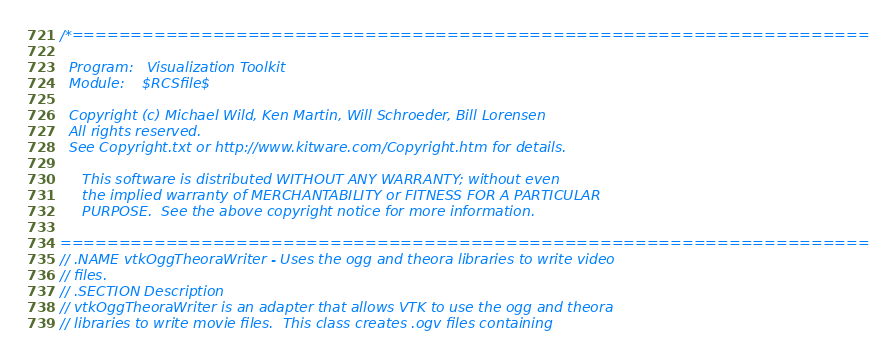Convert code to text. <code><loc_0><loc_0><loc_500><loc_500><_C_>/*=========================================================================

  Program:   Visualization Toolkit
  Module:    $RCSfile$

  Copyright (c) Michael Wild, Ken Martin, Will Schroeder, Bill Lorensen
  All rights reserved.
  See Copyright.txt or http://www.kitware.com/Copyright.htm for details.

     This software is distributed WITHOUT ANY WARRANTY; without even
     the implied warranty of MERCHANTABILITY or FITNESS FOR A PARTICULAR
     PURPOSE.  See the above copyright notice for more information.

=========================================================================*/
// .NAME vtkOggTheoraWriter - Uses the ogg and theora libraries to write video
// files.
// .SECTION Description
// vtkOggTheoraWriter is an adapter that allows VTK to use the ogg and theora
// libraries to write movie files.  This class creates .ogv files containing</code> 